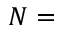Convert formula to latex. <formula><loc_0><loc_0><loc_500><loc_500>N =</formula> 